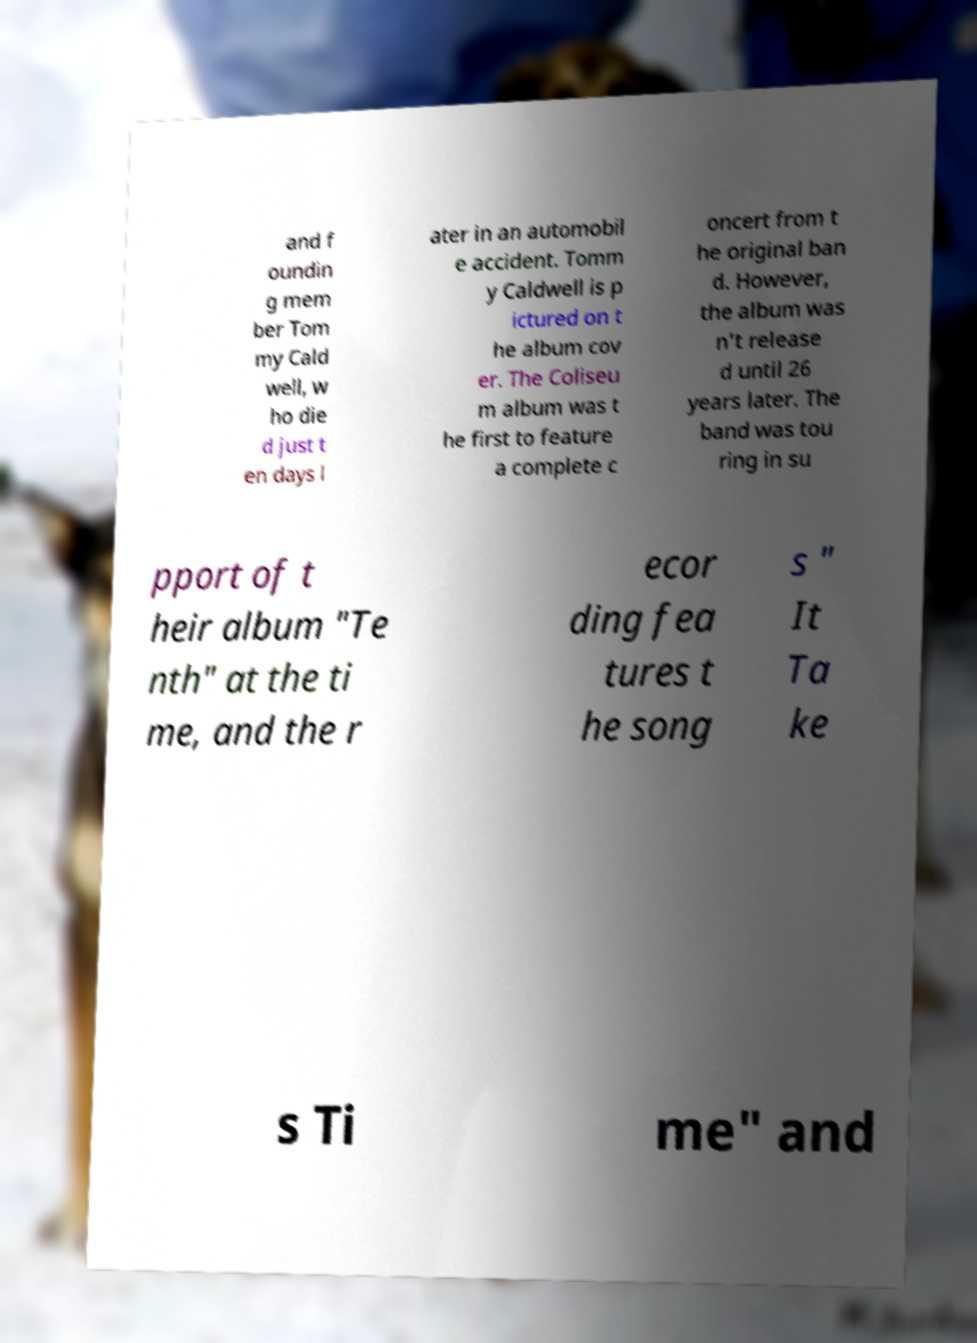I need the written content from this picture converted into text. Can you do that? and f oundin g mem ber Tom my Cald well, w ho die d just t en days l ater in an automobil e accident. Tomm y Caldwell is p ictured on t he album cov er. The Coliseu m album was t he first to feature a complete c oncert from t he original ban d. However, the album was n't release d until 26 years later. The band was tou ring in su pport of t heir album "Te nth" at the ti me, and the r ecor ding fea tures t he song s " It Ta ke s Ti me" and 